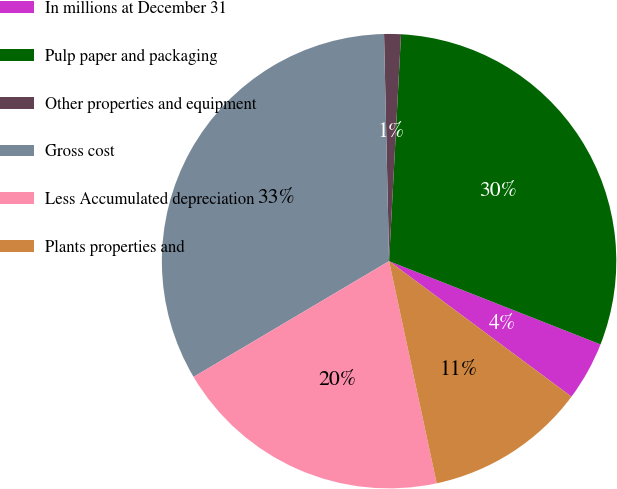<chart> <loc_0><loc_0><loc_500><loc_500><pie_chart><fcel>In millions at December 31<fcel>Pulp paper and packaging<fcel>Other properties and equipment<fcel>Gross cost<fcel>Less Accumulated depreciation<fcel>Plants properties and<nl><fcel>4.2%<fcel>30.13%<fcel>1.19%<fcel>33.15%<fcel>19.85%<fcel>11.47%<nl></chart> 